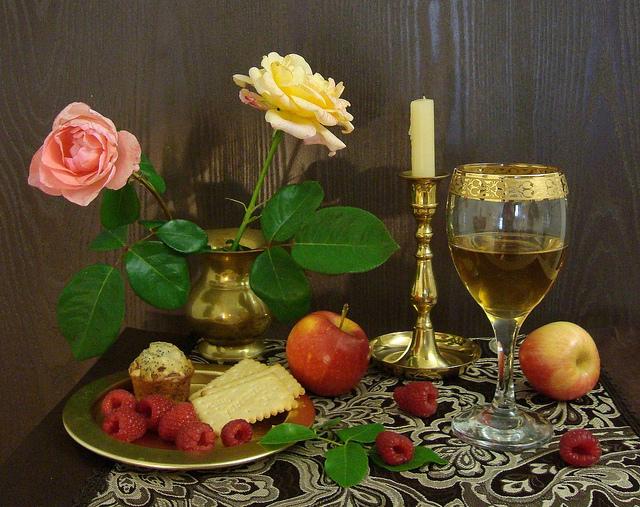What type of fruit do you see?
Answer briefly. Apple. Are the flowers both the same kind?
Give a very brief answer. Yes. What color is most represented here?
Short answer required. Red. Is this wine glass fancier than the average wine glass?
Short answer required. Yes. Are the plants fake?
Quick response, please. No. How many persimmons are in the display?
Concise answer only. 2. 